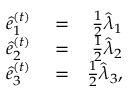<formula> <loc_0><loc_0><loc_500><loc_500>\begin{array} { r l r } { \hat { e } _ { 1 } ^ { ( t ) } } & = } & { \frac { 1 } { 2 } \hat { \lambda } _ { 1 } } \\ { \hat { e } _ { 2 } ^ { ( t ) } } & = } & { \frac { 1 } { 2 } \hat { \lambda } _ { 2 } } \\ { \hat { e } _ { 3 } ^ { ( t ) } } & = } & { \frac { 1 } { 2 } \hat { \lambda } _ { 3 } , } \end{array}</formula> 